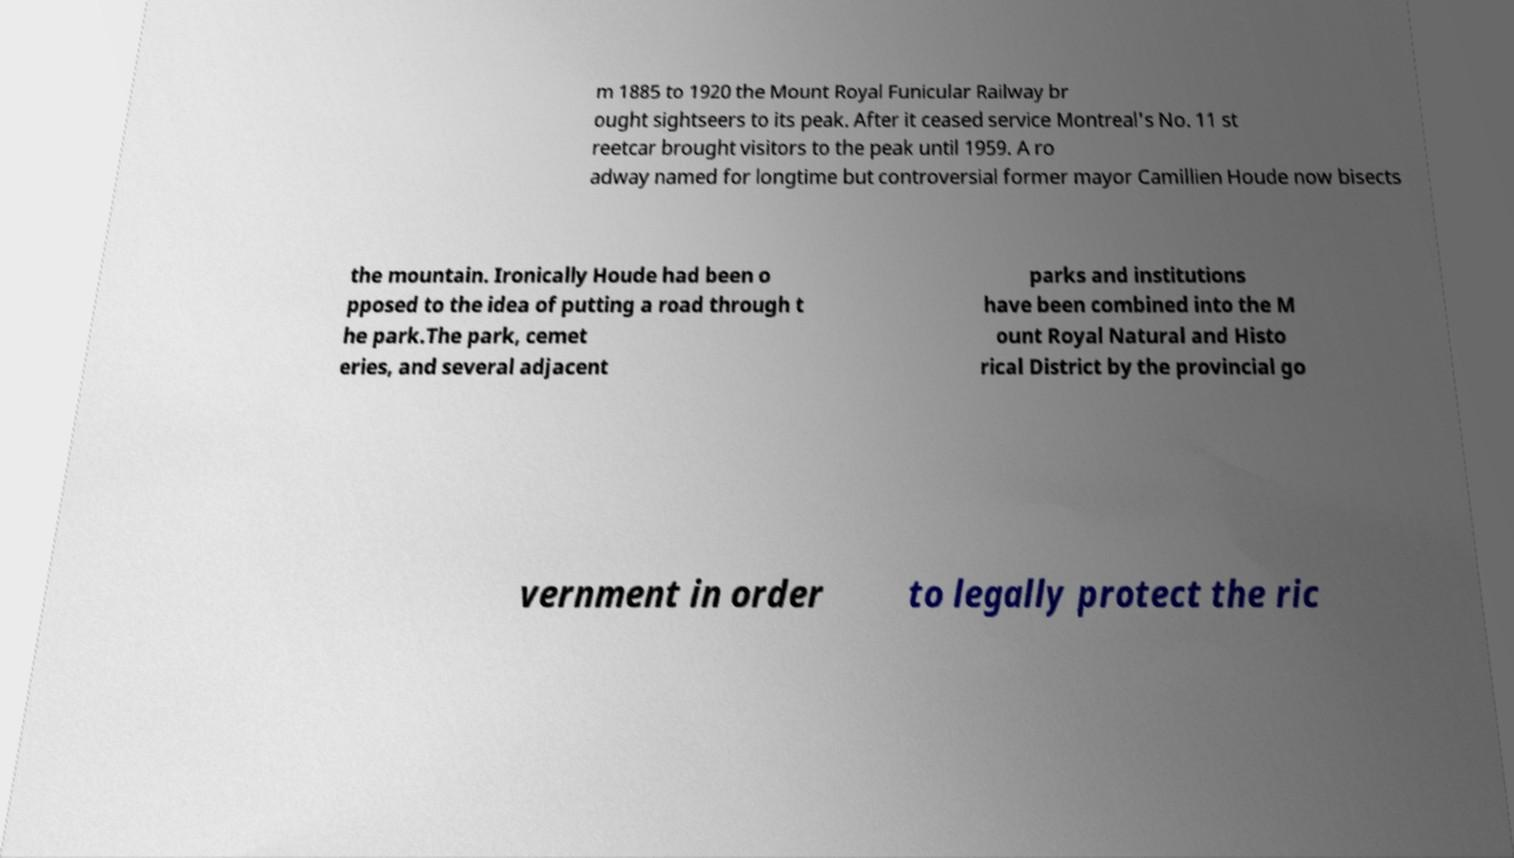Please read and relay the text visible in this image. What does it say? m 1885 to 1920 the Mount Royal Funicular Railway br ought sightseers to its peak. After it ceased service Montreal's No. 11 st reetcar brought visitors to the peak until 1959. A ro adway named for longtime but controversial former mayor Camillien Houde now bisects the mountain. Ironically Houde had been o pposed to the idea of putting a road through t he park.The park, cemet eries, and several adjacent parks and institutions have been combined into the M ount Royal Natural and Histo rical District by the provincial go vernment in order to legally protect the ric 